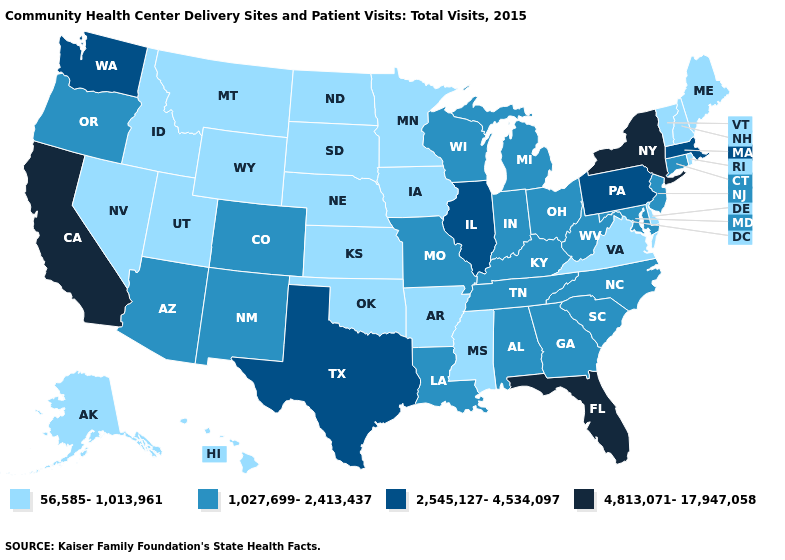Name the states that have a value in the range 4,813,071-17,947,058?
Give a very brief answer. California, Florida, New York. What is the value of Georgia?
Short answer required. 1,027,699-2,413,437. What is the value of Montana?
Concise answer only. 56,585-1,013,961. Among the states that border Maryland , which have the highest value?
Answer briefly. Pennsylvania. How many symbols are there in the legend?
Give a very brief answer. 4. Name the states that have a value in the range 2,545,127-4,534,097?
Write a very short answer. Illinois, Massachusetts, Pennsylvania, Texas, Washington. Name the states that have a value in the range 4,813,071-17,947,058?
Write a very short answer. California, Florida, New York. What is the highest value in the USA?
Answer briefly. 4,813,071-17,947,058. Does Wyoming have the same value as Nebraska?
Be succinct. Yes. Among the states that border Louisiana , which have the lowest value?
Quick response, please. Arkansas, Mississippi. How many symbols are there in the legend?
Concise answer only. 4. Among the states that border Louisiana , does Mississippi have the lowest value?
Short answer required. Yes. Which states have the lowest value in the USA?
Write a very short answer. Alaska, Arkansas, Delaware, Hawaii, Idaho, Iowa, Kansas, Maine, Minnesota, Mississippi, Montana, Nebraska, Nevada, New Hampshire, North Dakota, Oklahoma, Rhode Island, South Dakota, Utah, Vermont, Virginia, Wyoming. Which states hav the highest value in the MidWest?
Quick response, please. Illinois. Name the states that have a value in the range 4,813,071-17,947,058?
Answer briefly. California, Florida, New York. 